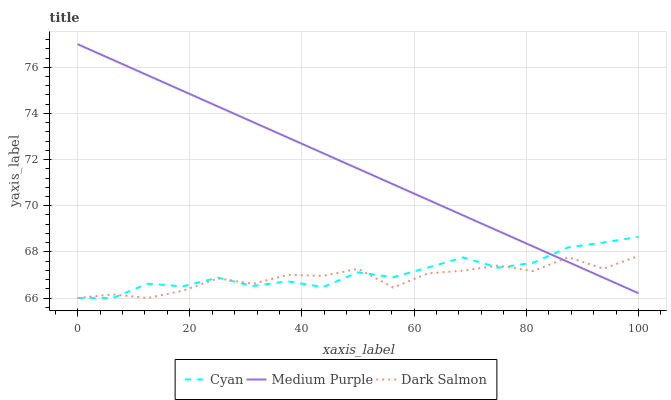Does Dark Salmon have the minimum area under the curve?
Answer yes or no. Yes. Does Medium Purple have the maximum area under the curve?
Answer yes or no. Yes. Does Cyan have the minimum area under the curve?
Answer yes or no. No. Does Cyan have the maximum area under the curve?
Answer yes or no. No. Is Medium Purple the smoothest?
Answer yes or no. Yes. Is Dark Salmon the roughest?
Answer yes or no. Yes. Is Cyan the smoothest?
Answer yes or no. No. Is Cyan the roughest?
Answer yes or no. No. Does Cyan have the lowest value?
Answer yes or no. Yes. Does Medium Purple have the highest value?
Answer yes or no. Yes. Does Cyan have the highest value?
Answer yes or no. No. Does Medium Purple intersect Cyan?
Answer yes or no. Yes. Is Medium Purple less than Cyan?
Answer yes or no. No. Is Medium Purple greater than Cyan?
Answer yes or no. No. 